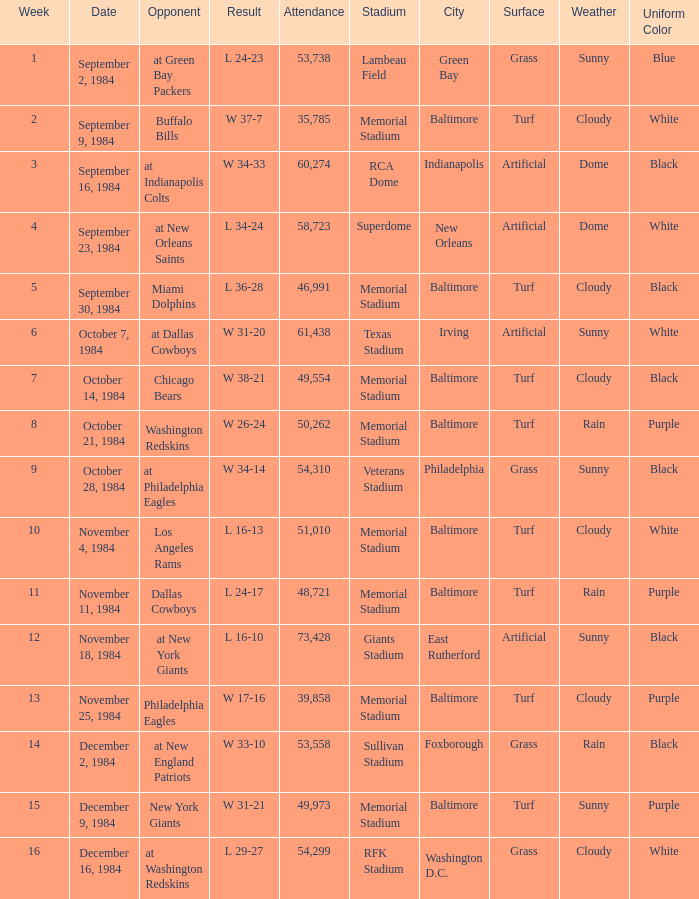Can you parse all the data within this table? {'header': ['Week', 'Date', 'Opponent', 'Result', 'Attendance', 'Stadium', 'City', 'Surface', 'Weather', 'Uniform Color'], 'rows': [['1', 'September 2, 1984', 'at Green Bay Packers', 'L 24-23', '53,738', 'Lambeau Field', 'Green Bay', 'Grass', 'Sunny', 'Blue'], ['2', 'September 9, 1984', 'Buffalo Bills', 'W 37-7', '35,785', 'Memorial Stadium', 'Baltimore', 'Turf', 'Cloudy', 'White'], ['3', 'September 16, 1984', 'at Indianapolis Colts', 'W 34-33', '60,274', 'RCA Dome', 'Indianapolis', 'Artificial', 'Dome', 'Black'], ['4', 'September 23, 1984', 'at New Orleans Saints', 'L 34-24', '58,723', 'Superdome', 'New Orleans', 'Artificial', 'Dome', 'White'], ['5', 'September 30, 1984', 'Miami Dolphins', 'L 36-28', '46,991', 'Memorial Stadium', 'Baltimore', 'Turf', 'Cloudy', 'Black'], ['6', 'October 7, 1984', 'at Dallas Cowboys', 'W 31-20', '61,438', 'Texas Stadium', 'Irving', 'Artificial', 'Sunny', 'White'], ['7', 'October 14, 1984', 'Chicago Bears', 'W 38-21', '49,554', 'Memorial Stadium', 'Baltimore', 'Turf', 'Cloudy', 'Black'], ['8', 'October 21, 1984', 'Washington Redskins', 'W 26-24', '50,262', 'Memorial Stadium', 'Baltimore', 'Turf', 'Rain', 'Purple'], ['9', 'October 28, 1984', 'at Philadelphia Eagles', 'W 34-14', '54,310', 'Veterans Stadium', 'Philadelphia', 'Grass', 'Sunny', 'Black'], ['10', 'November 4, 1984', 'Los Angeles Rams', 'L 16-13', '51,010', 'Memorial Stadium', 'Baltimore', 'Turf', 'Cloudy', 'White'], ['11', 'November 11, 1984', 'Dallas Cowboys', 'L 24-17', '48,721', 'Memorial Stadium', 'Baltimore', 'Turf', 'Rain', 'Purple'], ['12', 'November 18, 1984', 'at New York Giants', 'L 16-10', '73,428', 'Giants Stadium', 'East Rutherford', 'Artificial', 'Sunny', 'Black'], ['13', 'November 25, 1984', 'Philadelphia Eagles', 'W 17-16', '39,858', 'Memorial Stadium', 'Baltimore', 'Turf', 'Cloudy', 'Purple'], ['14', 'December 2, 1984', 'at New England Patriots', 'W 33-10', '53,558', 'Sullivan Stadium', 'Foxborough', 'Grass', 'Rain', 'Black'], ['15', 'December 9, 1984', 'New York Giants', 'W 31-21', '49,973', 'Memorial Stadium', 'Baltimore', 'Turf', 'Sunny', 'Purple'], ['16', 'December 16, 1984', 'at Washington Redskins', 'L 29-27', '54,299', 'RFK Stadium', 'Washington D.C.', 'Grass', 'Cloudy', 'White']]} What is the sum of attendance when the result was l 16-13? 51010.0. 